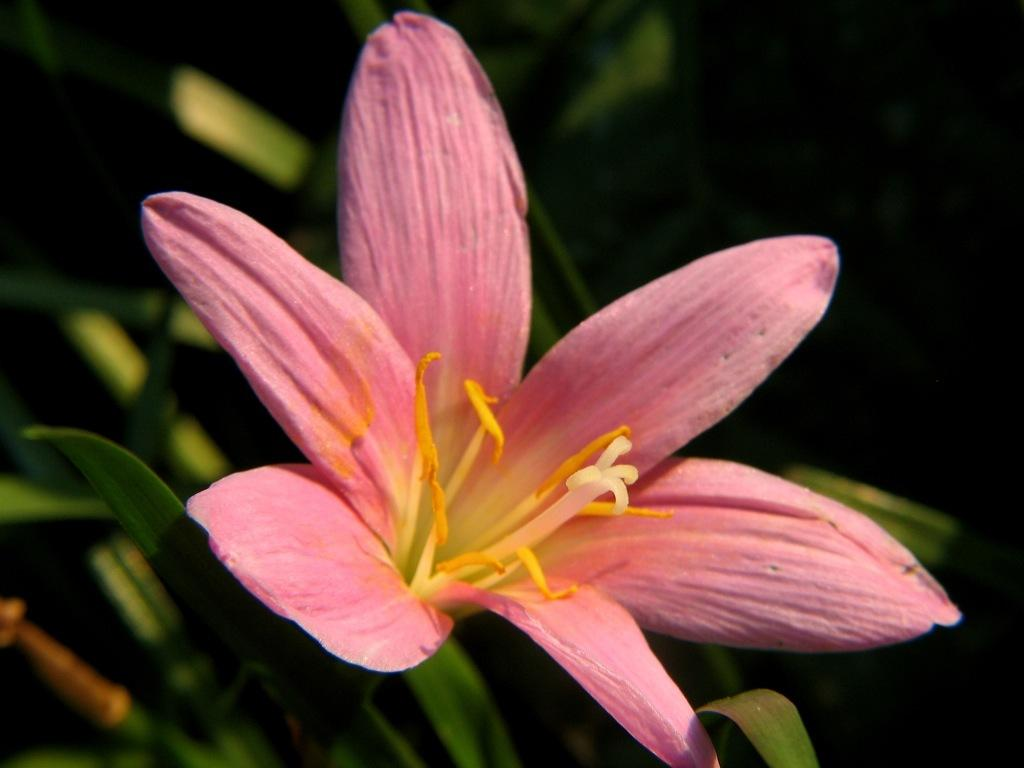What is present in the image? There is a plant in the image. What can be observed about the plant? The plant has a pink flower on it. What advice does the father give to the plant in the image? There is no father present in the image, and therefore no advice can be given. 